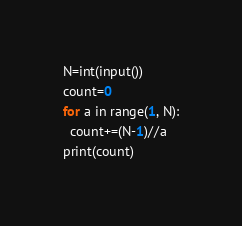<code> <loc_0><loc_0><loc_500><loc_500><_Python_>N=int(input())
count=0
for a in range(1, N):
  count+=(N-1)//a
print(count)</code> 